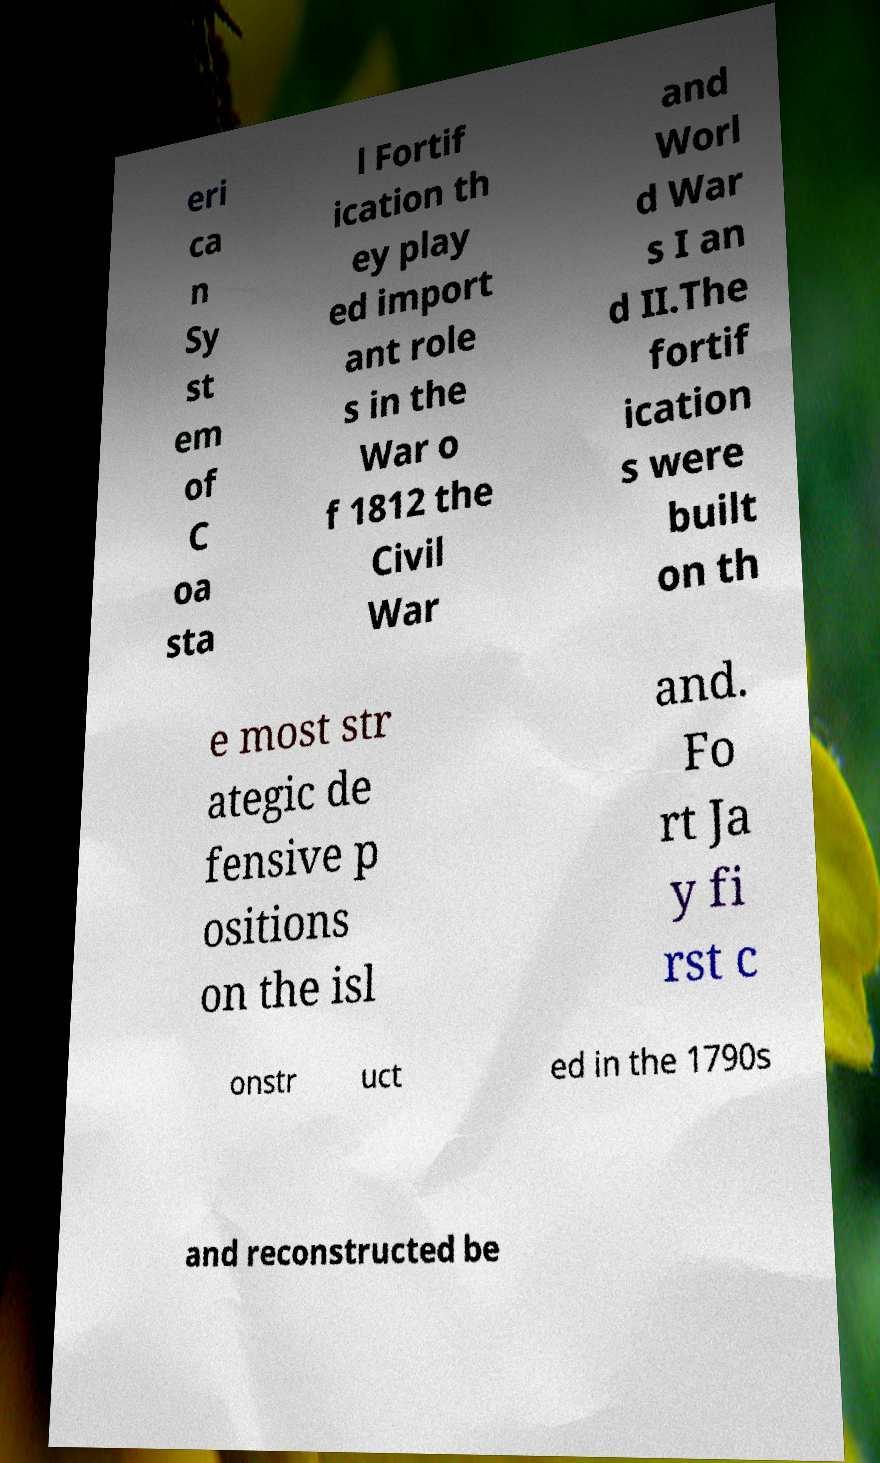Please identify and transcribe the text found in this image. eri ca n Sy st em of C oa sta l Fortif ication th ey play ed import ant role s in the War o f 1812 the Civil War and Worl d War s I an d II.The fortif ication s were built on th e most str ategic de fensive p ositions on the isl and. Fo rt Ja y fi rst c onstr uct ed in the 1790s and reconstructed be 